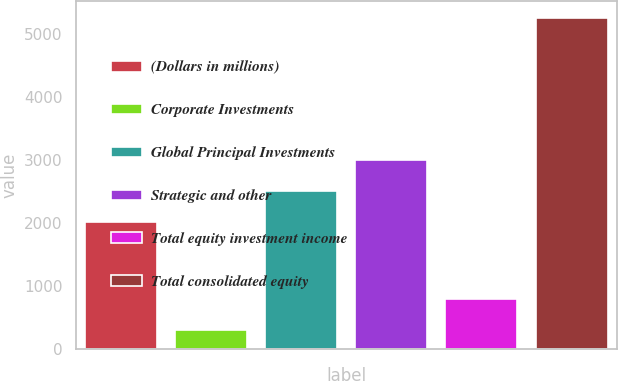Convert chart. <chart><loc_0><loc_0><loc_500><loc_500><bar_chart><fcel>(Dollars in millions)<fcel>Corporate Investments<fcel>Global Principal Investments<fcel>Strategic and other<fcel>Total equity investment income<fcel>Total consolidated equity<nl><fcel>2010<fcel>293<fcel>2506.7<fcel>3003.4<fcel>789.7<fcel>5260<nl></chart> 